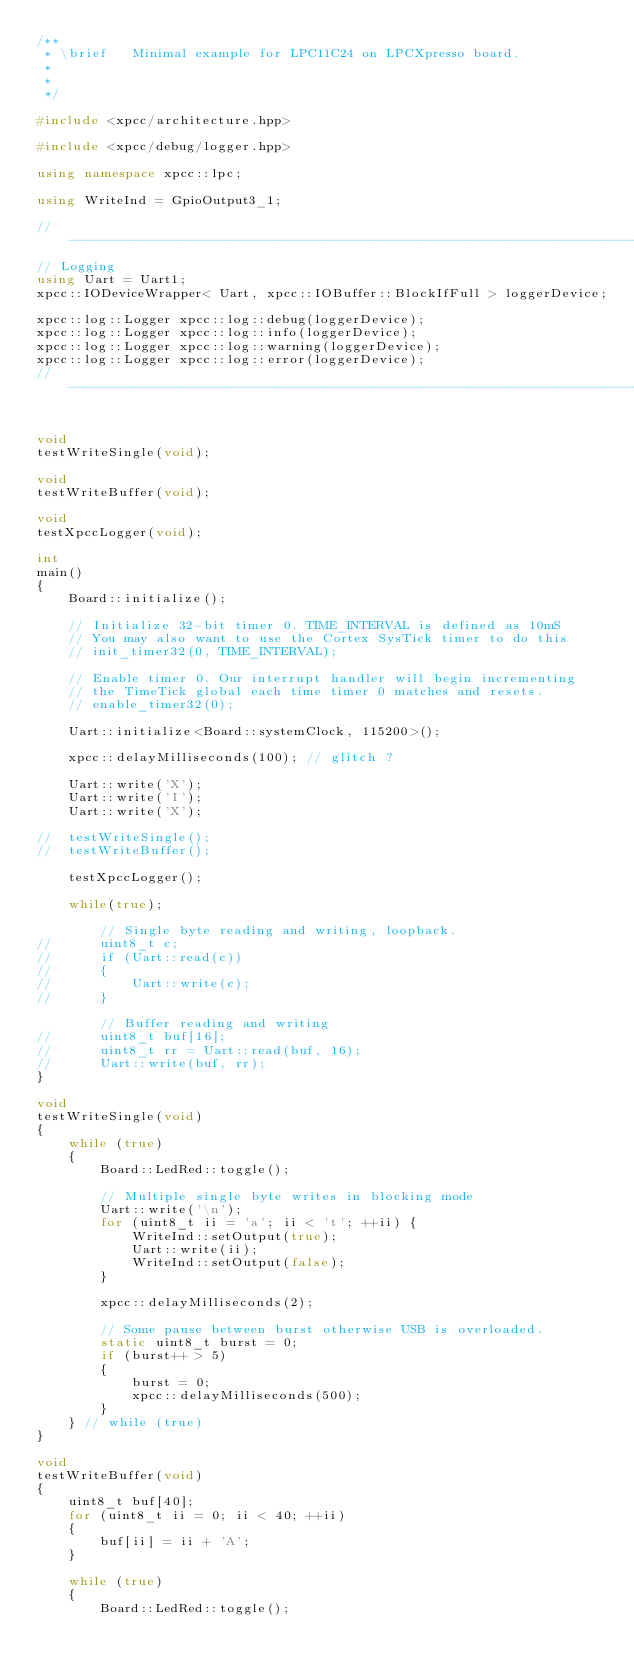<code> <loc_0><loc_0><loc_500><loc_500><_C++_>/**
 * \brief	Minimal example for LPC11C24 on LPCXpresso board.
 *
 *
 */

#include <xpcc/architecture.hpp>

#include <xpcc/debug/logger.hpp>

using namespace xpcc::lpc;

using WriteInd = GpioOutput3_1;

// ----------------------------------------------------------------------------
// Logging
using Uart = Uart1;
xpcc::IODeviceWrapper< Uart, xpcc::IOBuffer::BlockIfFull > loggerDevice;

xpcc::log::Logger xpcc::log::debug(loggerDevice);
xpcc::log::Logger xpcc::log::info(loggerDevice);
xpcc::log::Logger xpcc::log::warning(loggerDevice);
xpcc::log::Logger xpcc::log::error(loggerDevice);
// ----------------------------------------------------------------------------


void
testWriteSingle(void);

void
testWriteBuffer(void);

void
testXpccLogger(void);

int
main()
{
	Board::initialize();

	// Initialize 32-bit timer 0. TIME_INTERVAL is defined as 10mS
	// You may also want to use the Cortex SysTick timer to do this
	// init_timer32(0, TIME_INTERVAL);

	// Enable timer 0. Our interrupt handler will begin incrementing
	// the TimeTick global each time timer 0 matches and resets.
	// enable_timer32(0);

	Uart::initialize<Board::systemClock, 115200>();

	xpcc::delayMilliseconds(100); // glitch ?

	Uart::write('X');
	Uart::write('I');
	Uart::write('X');

//	testWriteSingle();
//	testWriteBuffer();

	testXpccLogger();

	while(true);

		// Single byte reading and writing, loopback.
//		uint8_t c;
//		if (Uart::read(c))
//		{
//			Uart::write(c);
//		}

		// Buffer reading and writing
//		uint8_t buf[16];
//		uint8_t rr = Uart::read(buf, 16);
//		Uart::write(buf, rr);
}

void
testWriteSingle(void)
{
	while (true)
	{
		Board::LedRed::toggle();

		// Multiple single byte writes in blocking mode
		Uart::write('\n');
		for (uint8_t ii = 'a'; ii < 't'; ++ii) {
			WriteInd::setOutput(true);
			Uart::write(ii);
			WriteInd::setOutput(false);
		}

		xpcc::delayMilliseconds(2);

		// Some pause between burst otherwise USB is overloaded.
		static uint8_t burst = 0;
		if (burst++ > 5)
		{
			burst = 0;
			xpcc::delayMilliseconds(500);
		}
	} // while (true)
}

void
testWriteBuffer(void)
{
	uint8_t buf[40];
	for (uint8_t ii = 0; ii < 40; ++ii)
	{
		buf[ii] = ii + 'A';
	}

	while (true)
	{
		Board::LedRed::toggle();
</code> 